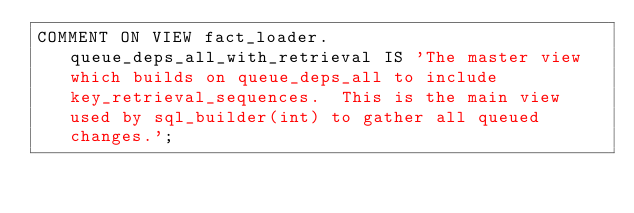Convert code to text. <code><loc_0><loc_0><loc_500><loc_500><_SQL_>COMMENT ON VIEW fact_loader.queue_deps_all_with_retrieval IS 'The master view which builds on queue_deps_all to include key_retrieval_sequences.  This is the main view used by sql_builder(int) to gather all queued changes.';
</code> 